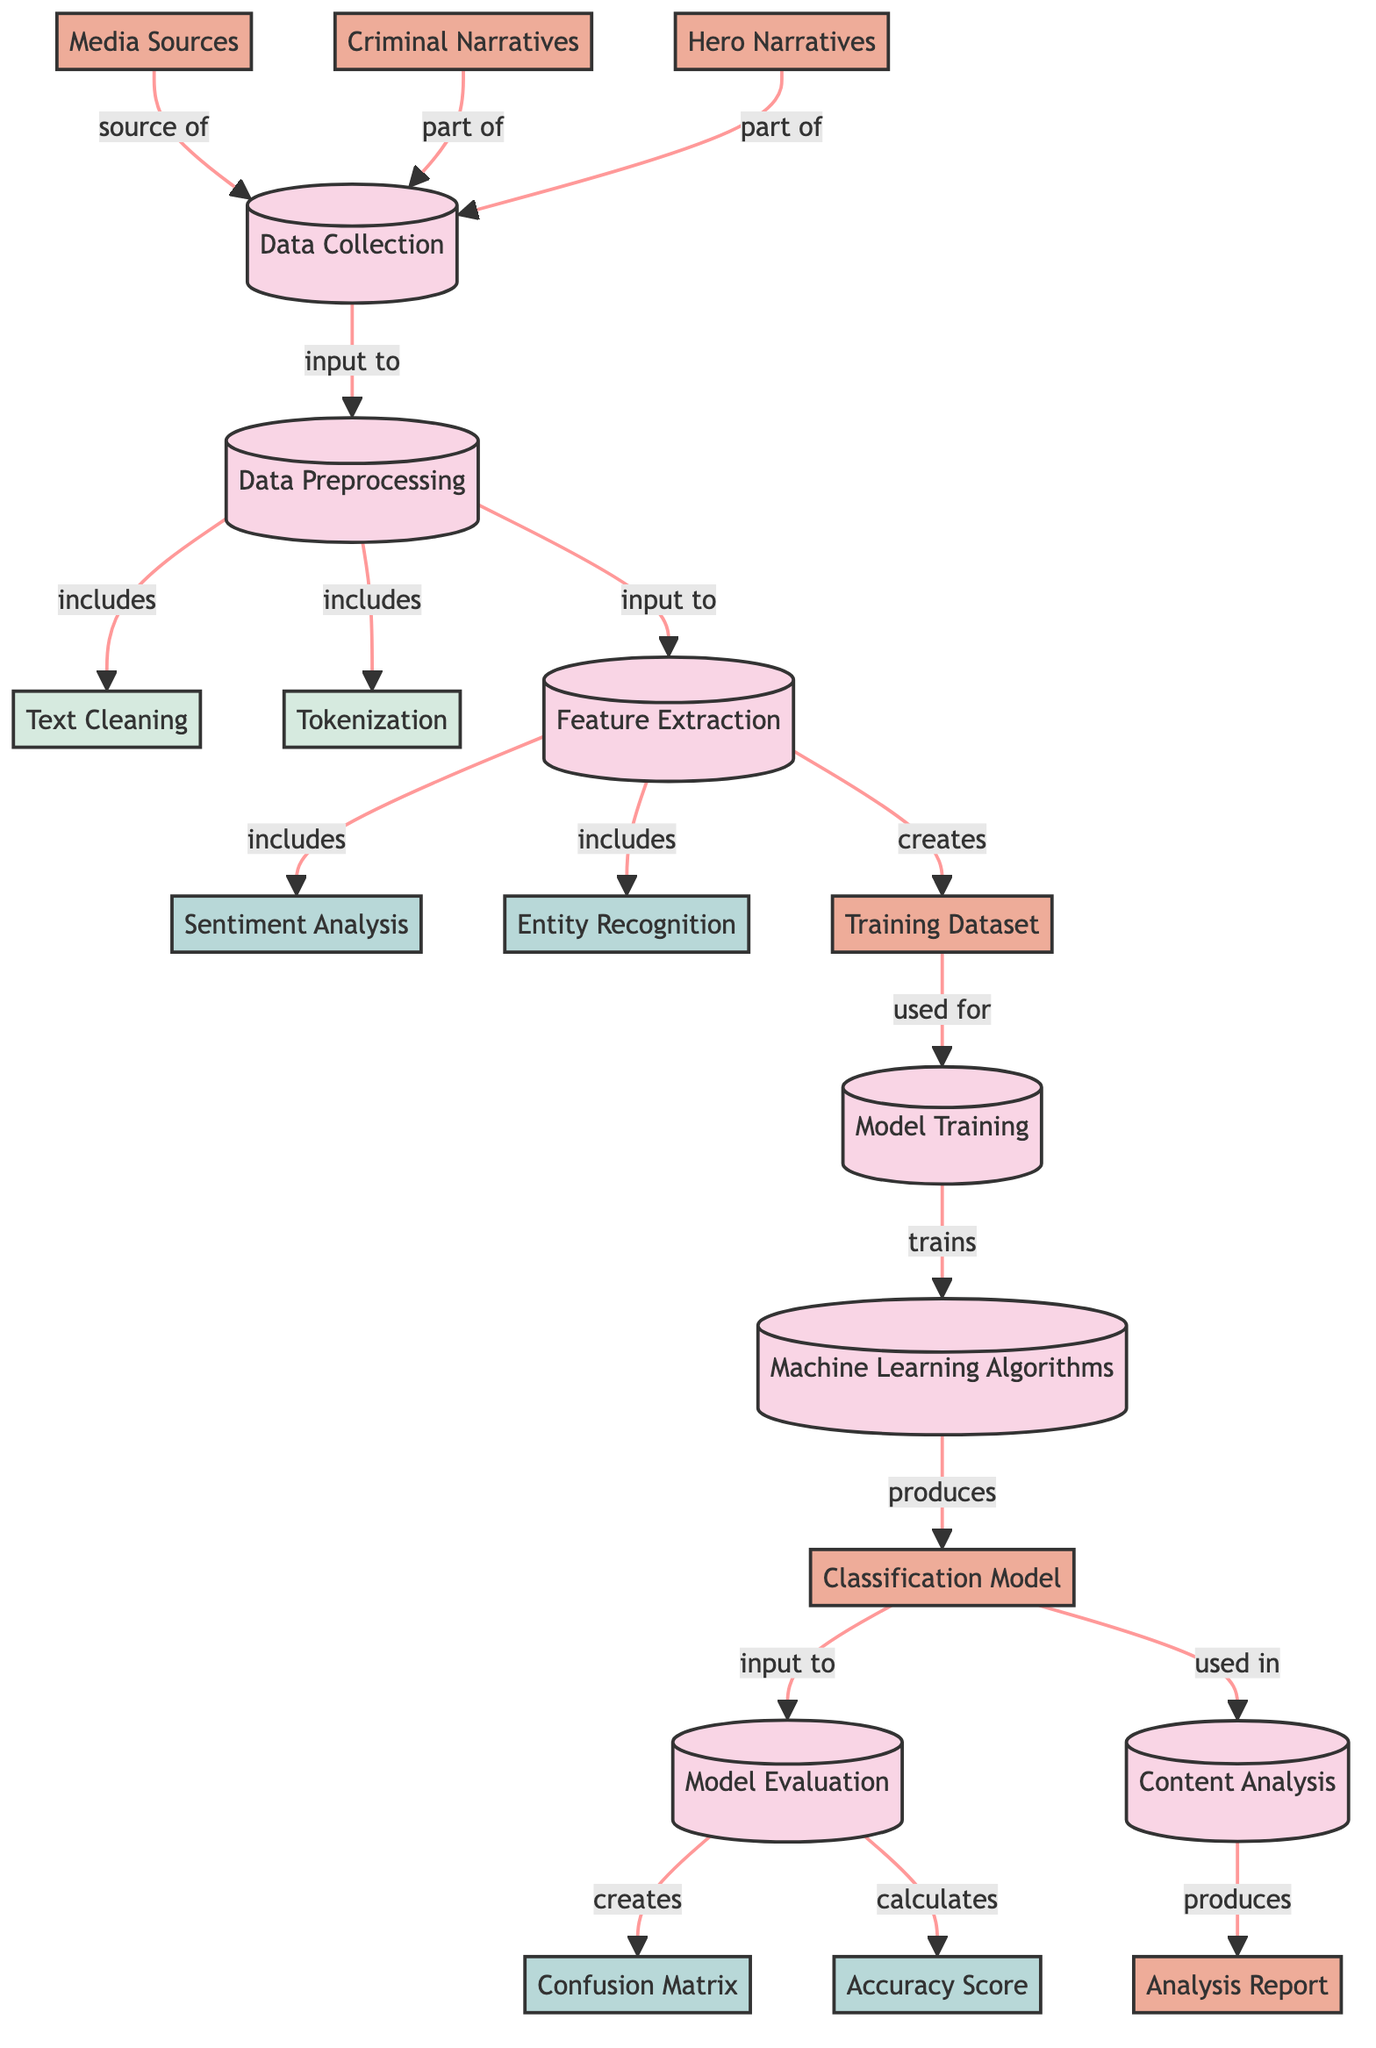What are the three types of narratives collected in the data collection phase? The data collection phase includes three types of narratives: Criminal Narratives, Hero Narratives, and Media Sources. These nodes explicitly point to the data sources involved.
Answer: Criminal Narratives, Hero Narratives, Media Sources How many subprocesses are involved in data preprocessing? The data preprocessing phase includes two subprocesses: Text Cleaning and Tokenization. This can be determined by counting the subprocess nodes connected under data preprocessing.
Answer: 2 What is the output of the feature extraction process? The feature extraction process creates a Training Dataset, indicated by the directed edge from the feature extraction node to the Training Dataset node.
Answer: Training Dataset Which method is used for evaluating the machine learning model? The methods used for evaluating the model include the Confusion Matrix and Accuracy Score. These methods are connected to the Model Evaluation process in the diagram.
Answer: Confusion Matrix, Accuracy Score What connects Model Training to Machine Learning Algorithms? The Training Dataset connects the Model Training to Machine Learning Algorithms as it is the input used to train the models. This relationship is shown through the directed edge from the Training Dataset node to Model Training.
Answer: Training Dataset Explain the flow from data collection to content analysis. The flow starts at the Data Collection phase, which feeds into Data Preprocessing. Then, the cleaned data goes into Feature Extraction, leading to Model Training, and finally to Model Evaluation. The model produced from this process is then used in Content Analysis, which results in an Analysis Report. This sequence shows the full progression of data handling and analysis as depicted in the diagram.
Answer: Data Collection ➔ Data Preprocessing ➔ Feature Extraction ➔ Model Training ➔ Model Evaluation ➔ Content Analysis What is the role of Sentiment Analysis in the diagram? Sentiment Analysis is one of the methods included in the Feature Extraction process, which aims to interpret the emotional tone behind the narratives in media content. Its position indicates it is part of the analysis to extract features relevant to criminal and hero narratives.
Answer: Extract features How many types of outputs does Model Evaluation produce? Model Evaluation produces two types of outputs: a Confusion Matrix and an Accuracy Score. This can be deduced by analyzing the nodes that are direct outputs from the Model Evaluation process.
Answer: 2 What is the main purpose of the classification model in this context? The main purpose of the classification model is to categorize media content into Criminal vs. Hero Narratives based on the features extracted from data. This is indicated by the node labeled "Classification Model" and its connections indicating its function in the overall diagram.
Answer: Categorization 